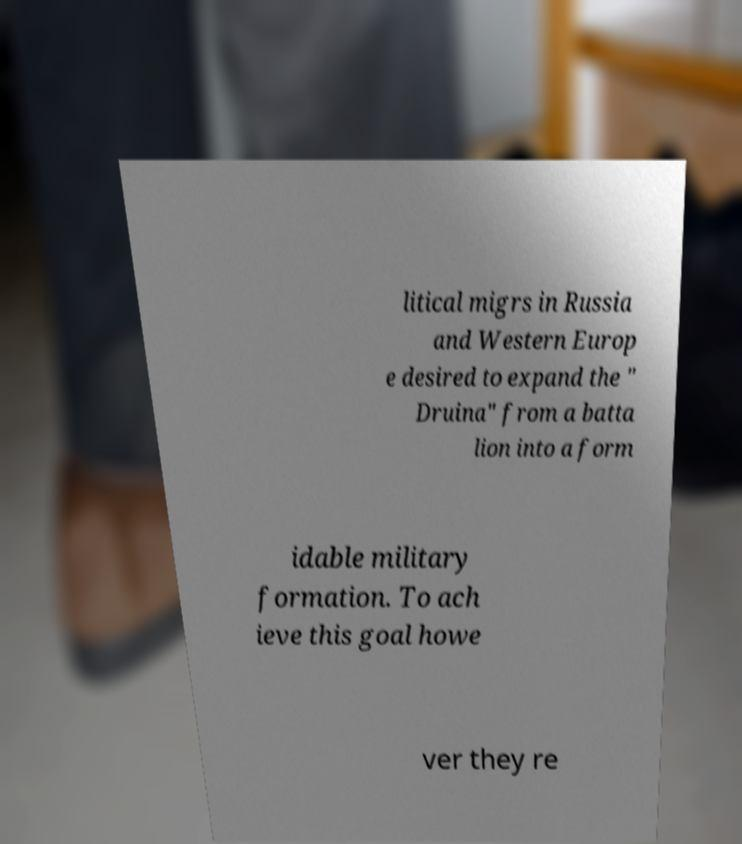Can you accurately transcribe the text from the provided image for me? litical migrs in Russia and Western Europ e desired to expand the " Druina" from a batta lion into a form idable military formation. To ach ieve this goal howe ver they re 